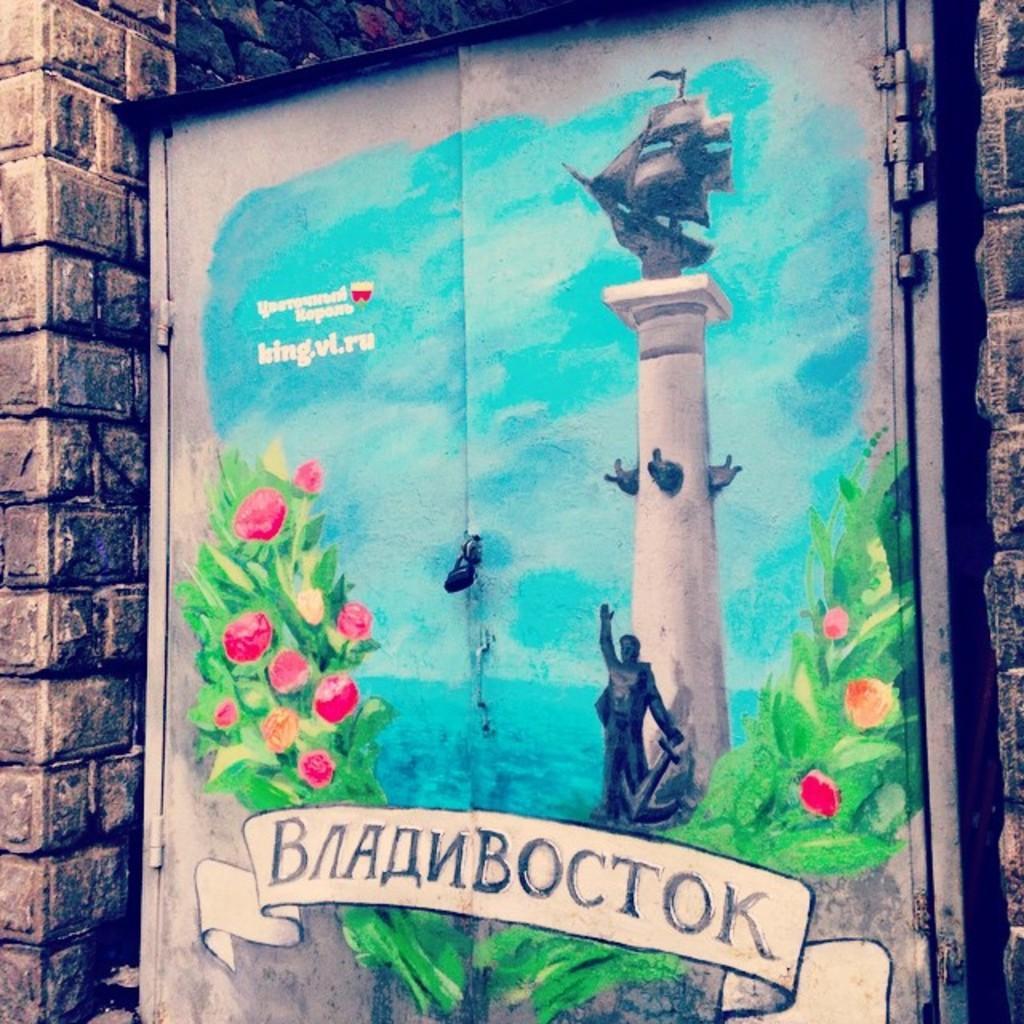Could you give a brief overview of what you see in this image? In this picture we can see a painting on doors and in this painting we can see flowers, leaves, statue, sky and in the background we can see brick wall. 